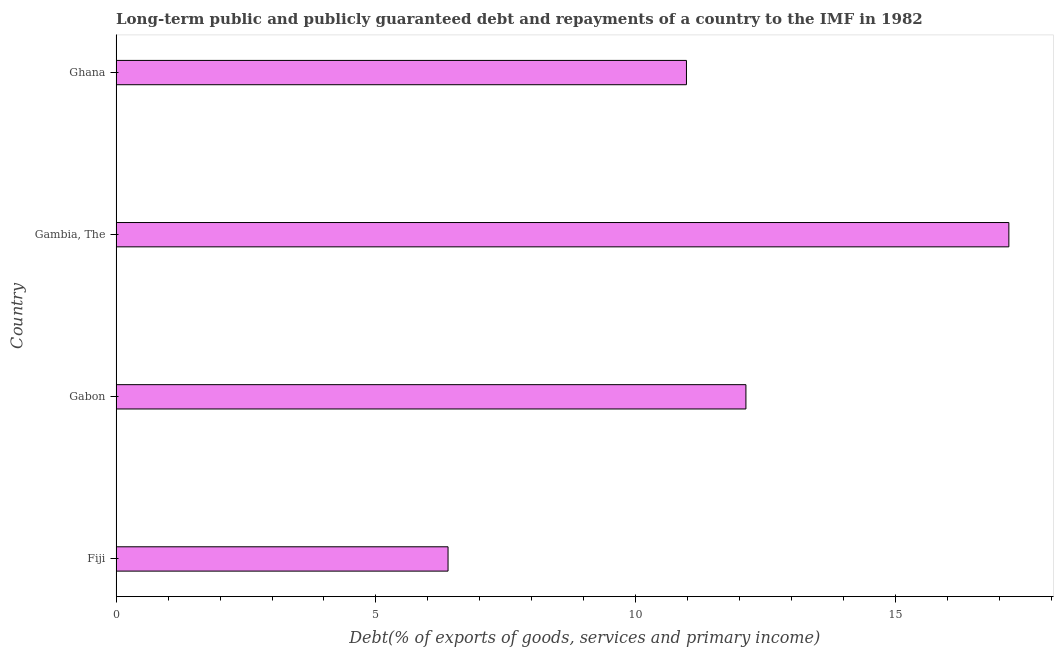Does the graph contain grids?
Give a very brief answer. No. What is the title of the graph?
Your answer should be compact. Long-term public and publicly guaranteed debt and repayments of a country to the IMF in 1982. What is the label or title of the X-axis?
Your answer should be very brief. Debt(% of exports of goods, services and primary income). What is the label or title of the Y-axis?
Your answer should be very brief. Country. What is the debt service in Gabon?
Provide a succinct answer. 12.12. Across all countries, what is the maximum debt service?
Your answer should be compact. 17.18. Across all countries, what is the minimum debt service?
Keep it short and to the point. 6.39. In which country was the debt service maximum?
Your response must be concise. Gambia, The. In which country was the debt service minimum?
Keep it short and to the point. Fiji. What is the sum of the debt service?
Your answer should be very brief. 46.67. What is the difference between the debt service in Fiji and Ghana?
Provide a short and direct response. -4.59. What is the average debt service per country?
Ensure brevity in your answer.  11.67. What is the median debt service?
Provide a succinct answer. 11.55. What is the ratio of the debt service in Gabon to that in Gambia, The?
Your response must be concise. 0.7. Is the debt service in Fiji less than that in Gabon?
Offer a very short reply. Yes. Is the difference between the debt service in Gabon and Ghana greater than the difference between any two countries?
Ensure brevity in your answer.  No. What is the difference between the highest and the second highest debt service?
Keep it short and to the point. 5.06. Is the sum of the debt service in Gambia, The and Ghana greater than the maximum debt service across all countries?
Provide a succinct answer. Yes. What is the difference between the highest and the lowest debt service?
Your answer should be very brief. 10.79. How many bars are there?
Give a very brief answer. 4. Are all the bars in the graph horizontal?
Offer a very short reply. Yes. How many countries are there in the graph?
Keep it short and to the point. 4. Are the values on the major ticks of X-axis written in scientific E-notation?
Provide a short and direct response. No. What is the Debt(% of exports of goods, services and primary income) of Fiji?
Your answer should be compact. 6.39. What is the Debt(% of exports of goods, services and primary income) in Gabon?
Your answer should be very brief. 12.12. What is the Debt(% of exports of goods, services and primary income) of Gambia, The?
Provide a short and direct response. 17.18. What is the Debt(% of exports of goods, services and primary income) in Ghana?
Ensure brevity in your answer.  10.98. What is the difference between the Debt(% of exports of goods, services and primary income) in Fiji and Gabon?
Make the answer very short. -5.73. What is the difference between the Debt(% of exports of goods, services and primary income) in Fiji and Gambia, The?
Offer a very short reply. -10.79. What is the difference between the Debt(% of exports of goods, services and primary income) in Fiji and Ghana?
Provide a succinct answer. -4.59. What is the difference between the Debt(% of exports of goods, services and primary income) in Gabon and Gambia, The?
Ensure brevity in your answer.  -5.06. What is the difference between the Debt(% of exports of goods, services and primary income) in Gabon and Ghana?
Your answer should be compact. 1.14. What is the difference between the Debt(% of exports of goods, services and primary income) in Gambia, The and Ghana?
Keep it short and to the point. 6.2. What is the ratio of the Debt(% of exports of goods, services and primary income) in Fiji to that in Gabon?
Offer a terse response. 0.53. What is the ratio of the Debt(% of exports of goods, services and primary income) in Fiji to that in Gambia, The?
Provide a succinct answer. 0.37. What is the ratio of the Debt(% of exports of goods, services and primary income) in Fiji to that in Ghana?
Ensure brevity in your answer.  0.58. What is the ratio of the Debt(% of exports of goods, services and primary income) in Gabon to that in Gambia, The?
Provide a short and direct response. 0.7. What is the ratio of the Debt(% of exports of goods, services and primary income) in Gabon to that in Ghana?
Give a very brief answer. 1.1. What is the ratio of the Debt(% of exports of goods, services and primary income) in Gambia, The to that in Ghana?
Ensure brevity in your answer.  1.56. 